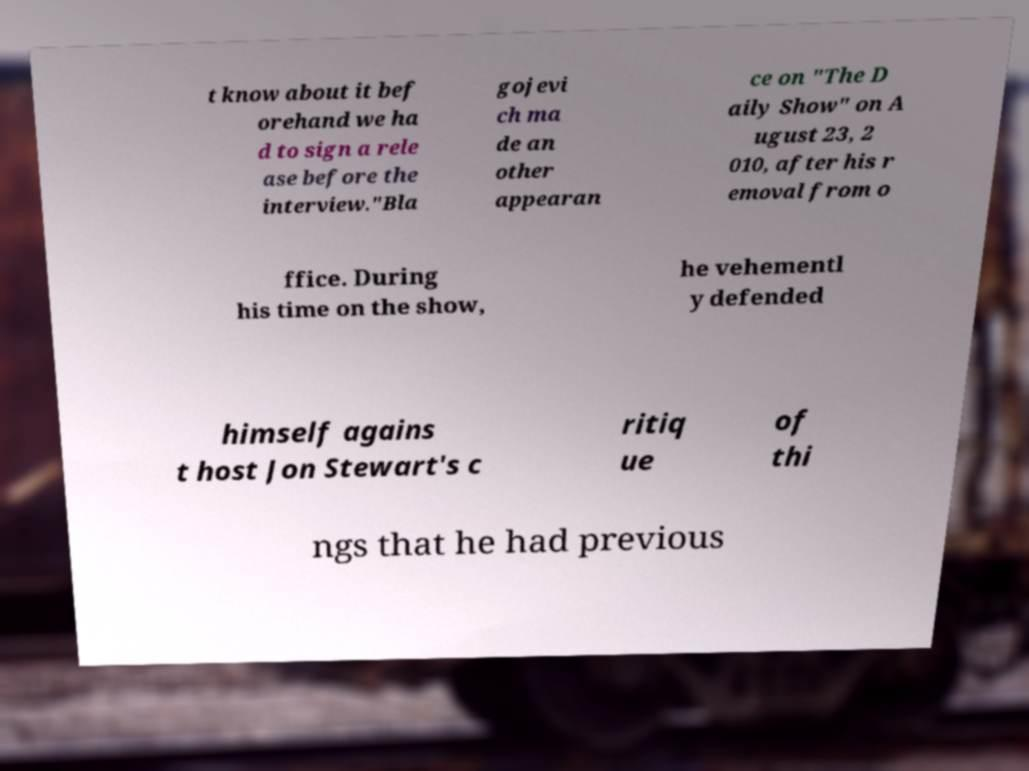I need the written content from this picture converted into text. Can you do that? t know about it bef orehand we ha d to sign a rele ase before the interview."Bla gojevi ch ma de an other appearan ce on "The D aily Show" on A ugust 23, 2 010, after his r emoval from o ffice. During his time on the show, he vehementl y defended himself agains t host Jon Stewart's c ritiq ue of thi ngs that he had previous 